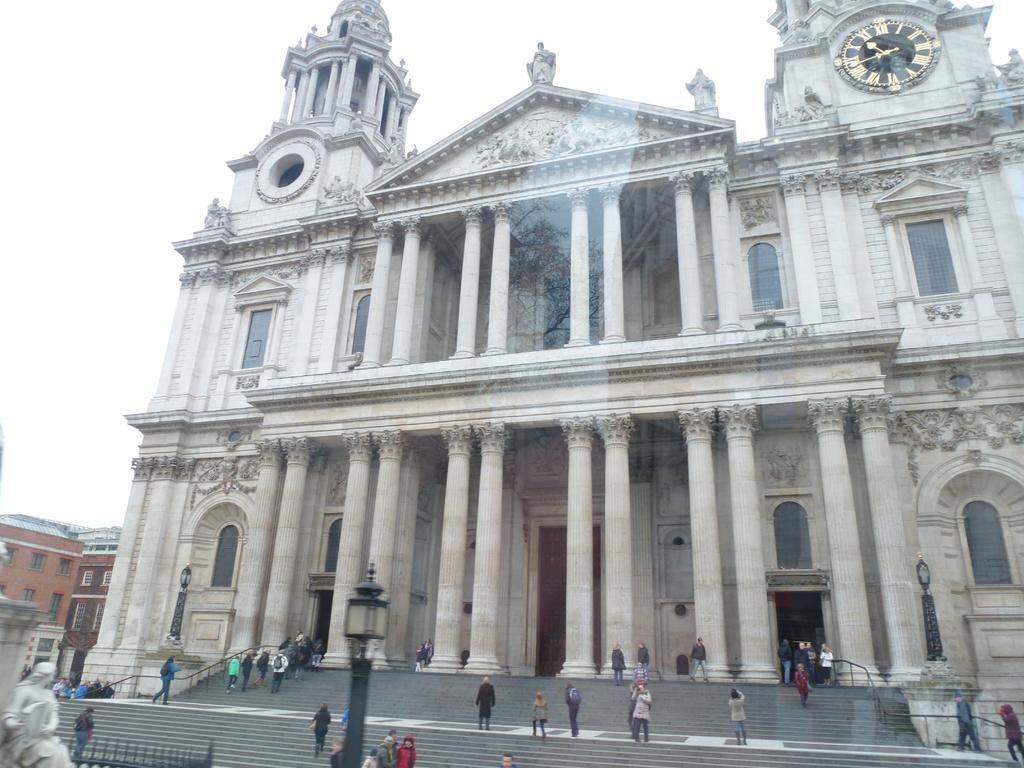Describe this image in one or two sentences. This picture describes about group of people, few people are seated, few are standing and few are walking, beside to them we can see few poles and lights, in the background we can find few buildings, in front of the building we can see a statue. 